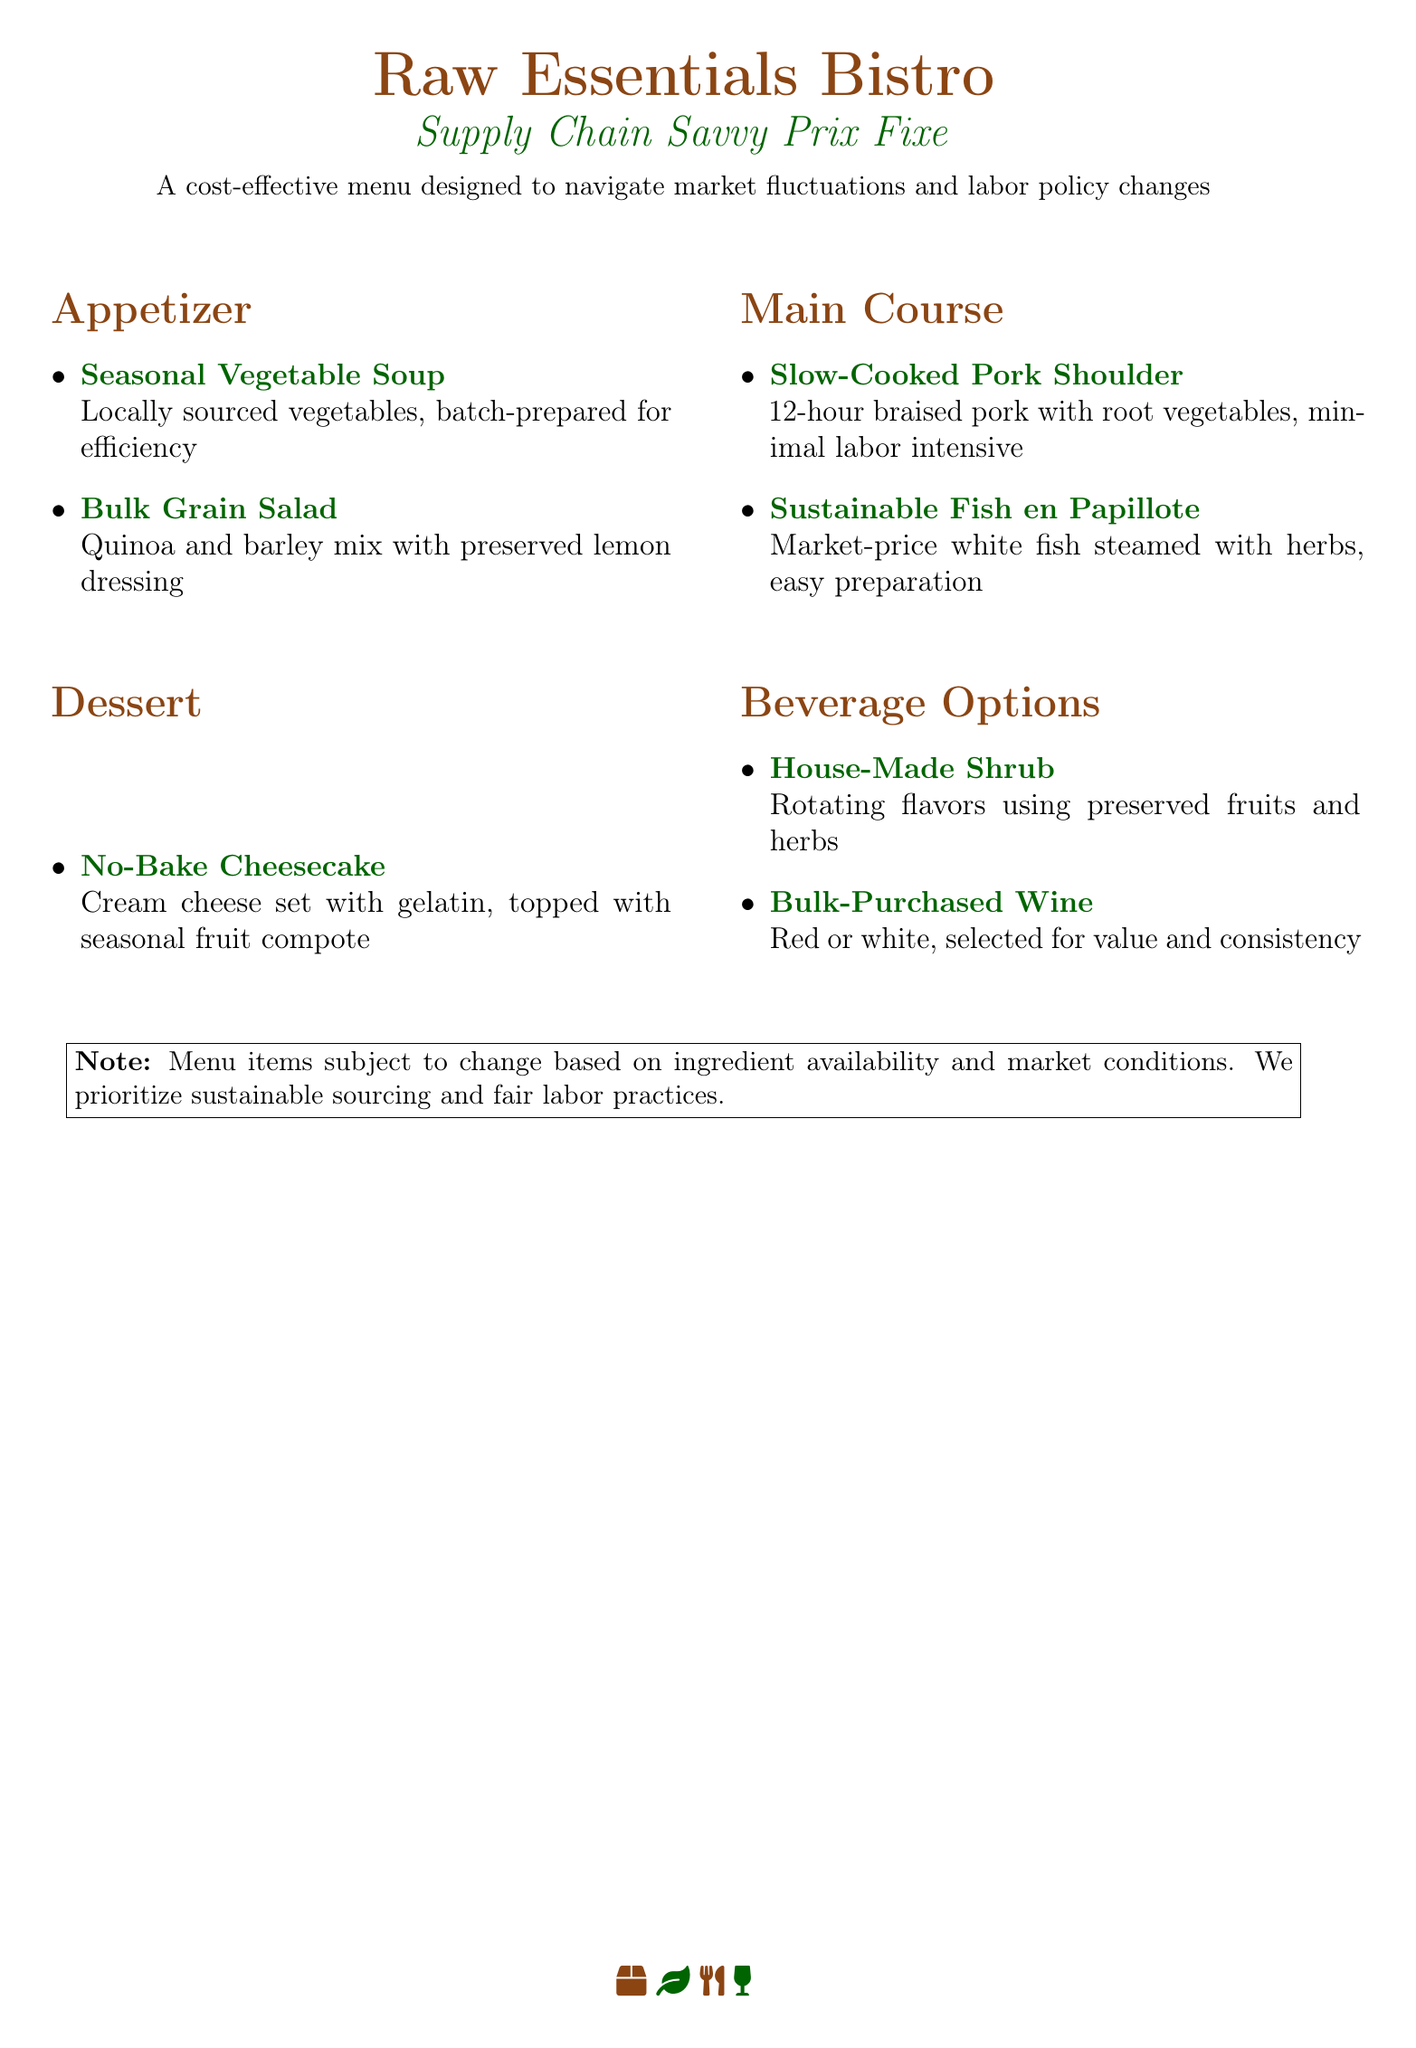What is the name of the bistro? The name of the bistro is explicitly mentioned at the top of the document.
Answer: Raw Essentials Bistro What type of menu is featured? The menu type is described at the top of the document, indicating its focus.
Answer: Prix Fixe Which dish is made with preserved lemon dressing? This dish is specified in the appetizer section with its ingredients.
Answer: Bulk Grain Salad How long is the pork shoulder cooked? The cooking time for this dish is noted in the main course section.
Answer: 12-hour What is the dessert item listed? The dessert item is identified in the dessert section of the menu.
Answer: No-Bake Cheesecake What beverage option features preserved fruits and herbs? This beverage option is specifically mentioned in the beverage section.
Answer: House-Made Shrub What defines the preparation of Sustainable Fish en Papillote? The mode of preparation for this dish is referred to in the main course section.
Answer: Easy preparation How does the menu indicate ingredient availability? The menu includes a note regarding this issue at the bottom.
Answer: Subject to change What is emphasized regarding sourcing and labor practices? This aspect is highlighted in the note section of the menu.
Answer: Sustainable sourcing and fair labor practices 